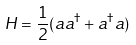<formula> <loc_0><loc_0><loc_500><loc_500>H = \frac { 1 } { 2 } ( a a ^ { \dagger } + a ^ { \dagger } a ) \</formula> 